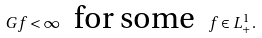<formula> <loc_0><loc_0><loc_500><loc_500>G f < \infty \ \text { for some } \ f \in L ^ { 1 } _ { + } .</formula> 